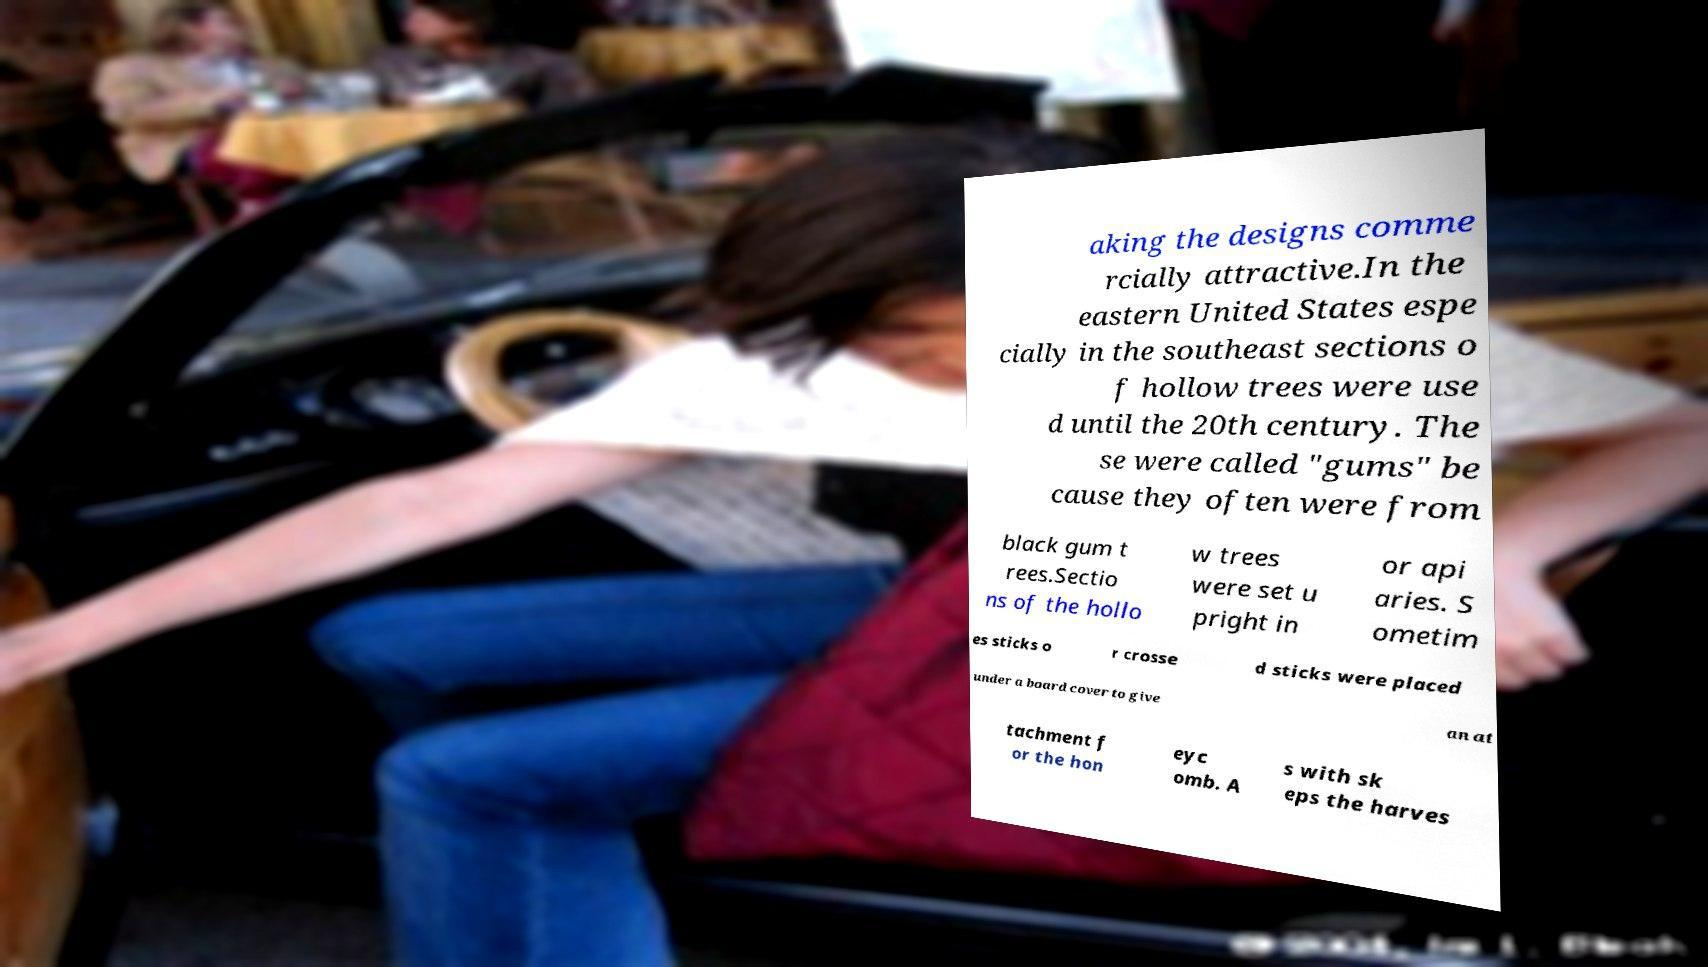Could you assist in decoding the text presented in this image and type it out clearly? aking the designs comme rcially attractive.In the eastern United States espe cially in the southeast sections o f hollow trees were use d until the 20th century. The se were called "gums" be cause they often were from black gum t rees.Sectio ns of the hollo w trees were set u pright in or api aries. S ometim es sticks o r crosse d sticks were placed under a board cover to give an at tachment f or the hon eyc omb. A s with sk eps the harves 